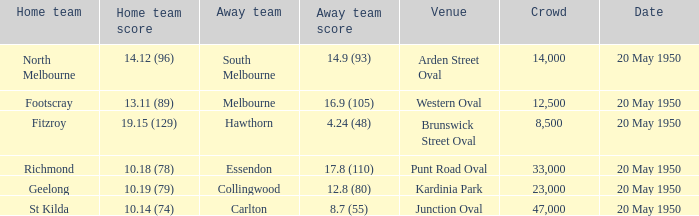In the game hosted at punt road oval, which team was the guest team? Essendon. 